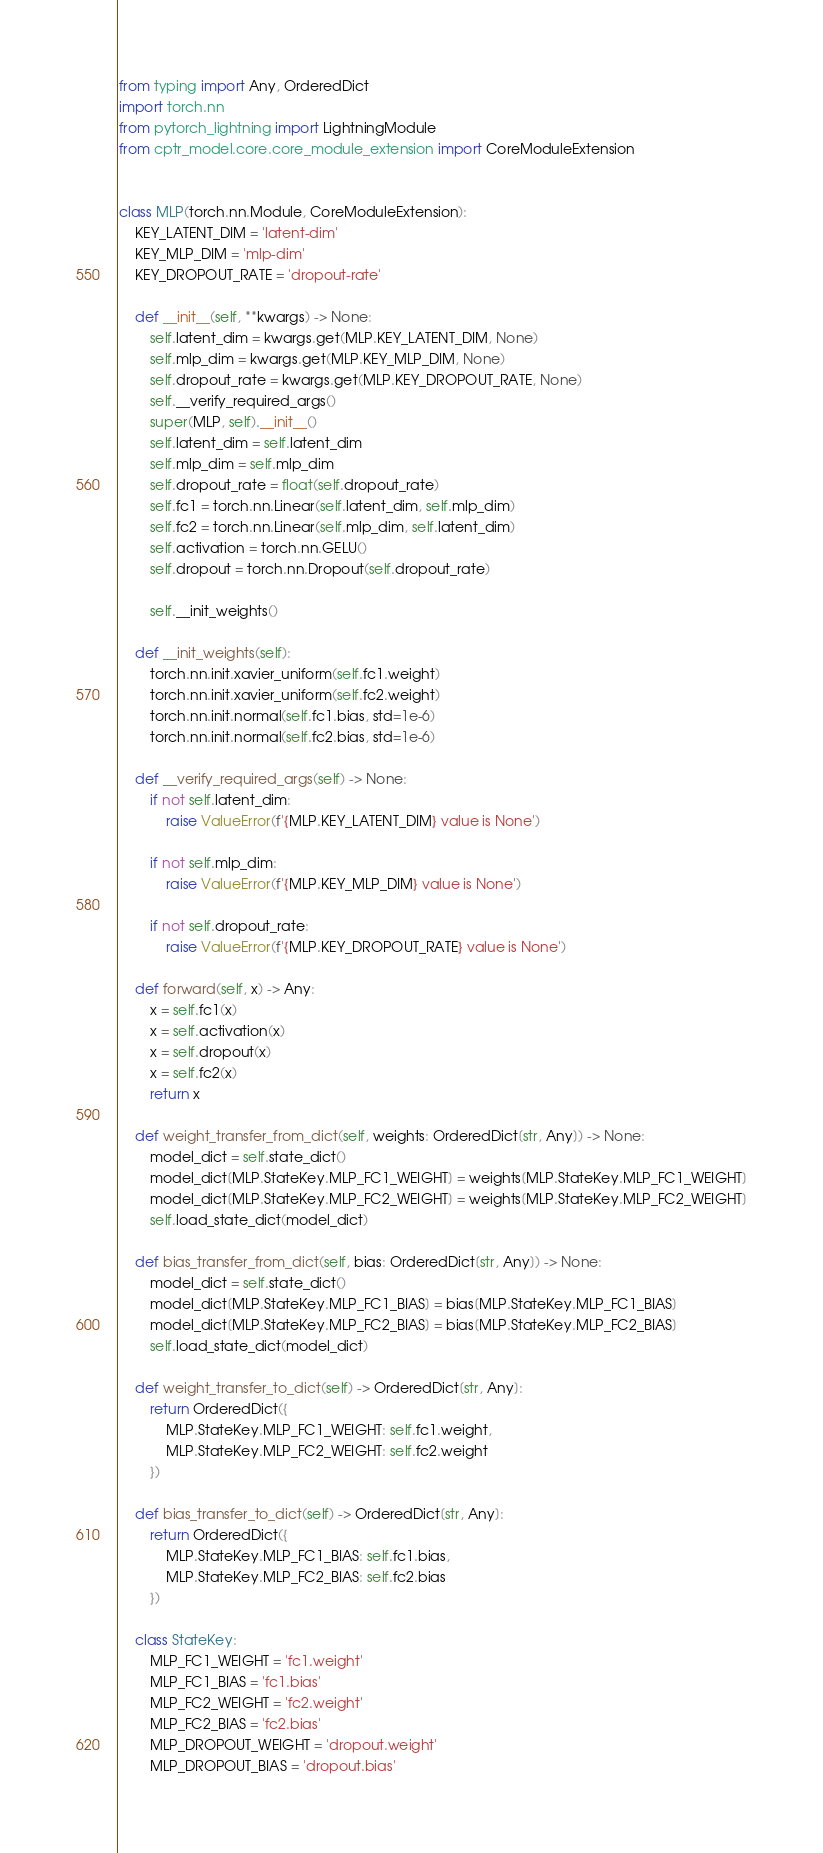Convert code to text. <code><loc_0><loc_0><loc_500><loc_500><_Python_>from typing import Any, OrderedDict
import torch.nn
from pytorch_lightning import LightningModule
from cptr_model.core.core_module_extension import CoreModuleExtension


class MLP(torch.nn.Module, CoreModuleExtension):
    KEY_LATENT_DIM = 'latent-dim'
    KEY_MLP_DIM = 'mlp-dim'
    KEY_DROPOUT_RATE = 'dropout-rate'

    def __init__(self, **kwargs) -> None:
        self.latent_dim = kwargs.get(MLP.KEY_LATENT_DIM, None)
        self.mlp_dim = kwargs.get(MLP.KEY_MLP_DIM, None)
        self.dropout_rate = kwargs.get(MLP.KEY_DROPOUT_RATE, None)
        self.__verify_required_args()
        super(MLP, self).__init__()
        self.latent_dim = self.latent_dim
        self.mlp_dim = self.mlp_dim
        self.dropout_rate = float(self.dropout_rate)
        self.fc1 = torch.nn.Linear(self.latent_dim, self.mlp_dim)
        self.fc2 = torch.nn.Linear(self.mlp_dim, self.latent_dim)
        self.activation = torch.nn.GELU()
        self.dropout = torch.nn.Dropout(self.dropout_rate)

        self.__init_weights()

    def __init_weights(self):
        torch.nn.init.xavier_uniform(self.fc1.weight)
        torch.nn.init.xavier_uniform(self.fc2.weight)
        torch.nn.init.normal(self.fc1.bias, std=1e-6)
        torch.nn.init.normal(self.fc2.bias, std=1e-6)

    def __verify_required_args(self) -> None:
        if not self.latent_dim:
            raise ValueError(f'{MLP.KEY_LATENT_DIM} value is None')

        if not self.mlp_dim:
            raise ValueError(f'{MLP.KEY_MLP_DIM} value is None')

        if not self.dropout_rate:
            raise ValueError(f'{MLP.KEY_DROPOUT_RATE} value is None')

    def forward(self, x) -> Any:
        x = self.fc1(x)
        x = self.activation(x)
        x = self.dropout(x)
        x = self.fc2(x)
        return x

    def weight_transfer_from_dict(self, weights: OrderedDict[str, Any]) -> None:
        model_dict = self.state_dict()
        model_dict[MLP.StateKey.MLP_FC1_WEIGHT] = weights[MLP.StateKey.MLP_FC1_WEIGHT]
        model_dict[MLP.StateKey.MLP_FC2_WEIGHT] = weights[MLP.StateKey.MLP_FC2_WEIGHT]
        self.load_state_dict(model_dict)

    def bias_transfer_from_dict(self, bias: OrderedDict[str, Any]) -> None:
        model_dict = self.state_dict()
        model_dict[MLP.StateKey.MLP_FC1_BIAS] = bias[MLP.StateKey.MLP_FC1_BIAS]
        model_dict[MLP.StateKey.MLP_FC2_BIAS] = bias[MLP.StateKey.MLP_FC2_BIAS]
        self.load_state_dict(model_dict)

    def weight_transfer_to_dict(self) -> OrderedDict[str, Any]:
        return OrderedDict({
            MLP.StateKey.MLP_FC1_WEIGHT: self.fc1.weight,
            MLP.StateKey.MLP_FC2_WEIGHT: self.fc2.weight
        })

    def bias_transfer_to_dict(self) -> OrderedDict[str, Any]:
        return OrderedDict({
            MLP.StateKey.MLP_FC1_BIAS: self.fc1.bias,
            MLP.StateKey.MLP_FC2_BIAS: self.fc2.bias
        })

    class StateKey:
        MLP_FC1_WEIGHT = 'fc1.weight'
        MLP_FC1_BIAS = 'fc1.bias'
        MLP_FC2_WEIGHT = 'fc2.weight'
        MLP_FC2_BIAS = 'fc2.bias'
        MLP_DROPOUT_WEIGHT = 'dropout.weight'
        MLP_DROPOUT_BIAS = 'dropout.bias'</code> 